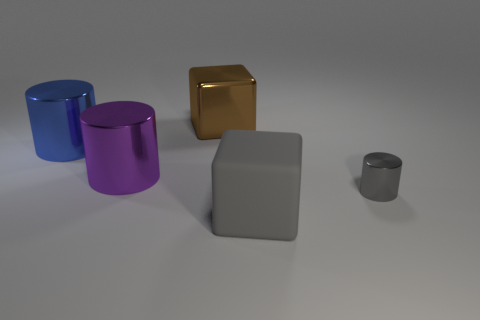Add 2 large purple objects. How many objects exist? 7 Subtract all cylinders. How many objects are left? 2 Subtract 1 blue cylinders. How many objects are left? 4 Subtract all big gray objects. Subtract all big rubber cubes. How many objects are left? 3 Add 5 gray rubber things. How many gray rubber things are left? 6 Add 5 large rubber spheres. How many large rubber spheres exist? 5 